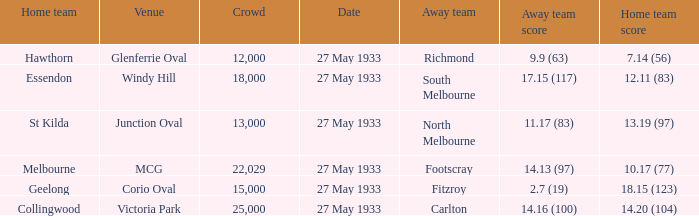In the match where the away team scored 2.7 (19), how many peopel were in the crowd? 15000.0. 